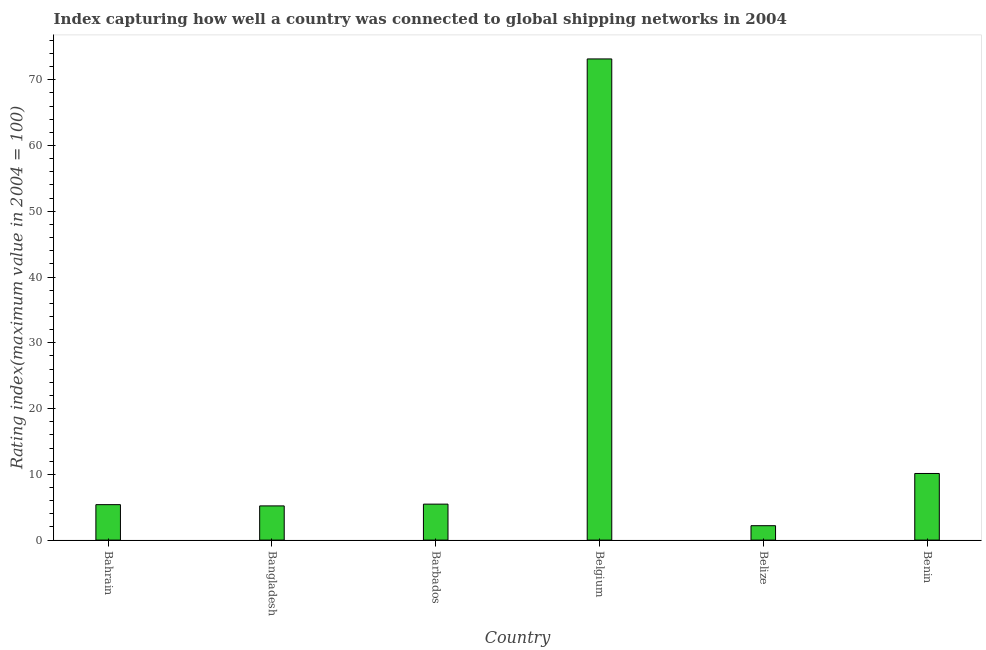Does the graph contain any zero values?
Offer a terse response. No. What is the title of the graph?
Make the answer very short. Index capturing how well a country was connected to global shipping networks in 2004. What is the label or title of the Y-axis?
Your response must be concise. Rating index(maximum value in 2004 = 100). What is the liner shipping connectivity index in Bahrain?
Ensure brevity in your answer.  5.39. Across all countries, what is the maximum liner shipping connectivity index?
Offer a very short reply. 73.16. Across all countries, what is the minimum liner shipping connectivity index?
Ensure brevity in your answer.  2.19. In which country was the liner shipping connectivity index maximum?
Ensure brevity in your answer.  Belgium. In which country was the liner shipping connectivity index minimum?
Make the answer very short. Belize. What is the sum of the liner shipping connectivity index?
Ensure brevity in your answer.  101.54. What is the difference between the liner shipping connectivity index in Bangladesh and Barbados?
Give a very brief answer. -0.27. What is the average liner shipping connectivity index per country?
Offer a very short reply. 16.92. What is the median liner shipping connectivity index?
Your answer should be very brief. 5.43. What is the ratio of the liner shipping connectivity index in Bahrain to that in Belize?
Give a very brief answer. 2.46. Is the liner shipping connectivity index in Belize less than that in Benin?
Give a very brief answer. Yes. What is the difference between the highest and the second highest liner shipping connectivity index?
Provide a short and direct response. 63.03. Is the sum of the liner shipping connectivity index in Belize and Benin greater than the maximum liner shipping connectivity index across all countries?
Make the answer very short. No. What is the difference between the highest and the lowest liner shipping connectivity index?
Give a very brief answer. 70.97. In how many countries, is the liner shipping connectivity index greater than the average liner shipping connectivity index taken over all countries?
Your response must be concise. 1. Are all the bars in the graph horizontal?
Ensure brevity in your answer.  No. What is the Rating index(maximum value in 2004 = 100) of Bahrain?
Offer a very short reply. 5.39. What is the Rating index(maximum value in 2004 = 100) in Barbados?
Your answer should be very brief. 5.47. What is the Rating index(maximum value in 2004 = 100) in Belgium?
Offer a very short reply. 73.16. What is the Rating index(maximum value in 2004 = 100) in Belize?
Offer a very short reply. 2.19. What is the Rating index(maximum value in 2004 = 100) of Benin?
Your response must be concise. 10.13. What is the difference between the Rating index(maximum value in 2004 = 100) in Bahrain and Bangladesh?
Ensure brevity in your answer.  0.19. What is the difference between the Rating index(maximum value in 2004 = 100) in Bahrain and Barbados?
Your response must be concise. -0.08. What is the difference between the Rating index(maximum value in 2004 = 100) in Bahrain and Belgium?
Keep it short and to the point. -67.77. What is the difference between the Rating index(maximum value in 2004 = 100) in Bahrain and Benin?
Offer a very short reply. -4.74. What is the difference between the Rating index(maximum value in 2004 = 100) in Bangladesh and Barbados?
Offer a very short reply. -0.27. What is the difference between the Rating index(maximum value in 2004 = 100) in Bangladesh and Belgium?
Provide a succinct answer. -67.96. What is the difference between the Rating index(maximum value in 2004 = 100) in Bangladesh and Belize?
Your answer should be compact. 3.01. What is the difference between the Rating index(maximum value in 2004 = 100) in Bangladesh and Benin?
Ensure brevity in your answer.  -4.93. What is the difference between the Rating index(maximum value in 2004 = 100) in Barbados and Belgium?
Your response must be concise. -67.69. What is the difference between the Rating index(maximum value in 2004 = 100) in Barbados and Belize?
Keep it short and to the point. 3.28. What is the difference between the Rating index(maximum value in 2004 = 100) in Barbados and Benin?
Give a very brief answer. -4.66. What is the difference between the Rating index(maximum value in 2004 = 100) in Belgium and Belize?
Your answer should be very brief. 70.97. What is the difference between the Rating index(maximum value in 2004 = 100) in Belgium and Benin?
Keep it short and to the point. 63.03. What is the difference between the Rating index(maximum value in 2004 = 100) in Belize and Benin?
Offer a terse response. -7.94. What is the ratio of the Rating index(maximum value in 2004 = 100) in Bahrain to that in Bangladesh?
Your answer should be compact. 1.04. What is the ratio of the Rating index(maximum value in 2004 = 100) in Bahrain to that in Belgium?
Give a very brief answer. 0.07. What is the ratio of the Rating index(maximum value in 2004 = 100) in Bahrain to that in Belize?
Provide a succinct answer. 2.46. What is the ratio of the Rating index(maximum value in 2004 = 100) in Bahrain to that in Benin?
Offer a terse response. 0.53. What is the ratio of the Rating index(maximum value in 2004 = 100) in Bangladesh to that in Barbados?
Offer a terse response. 0.95. What is the ratio of the Rating index(maximum value in 2004 = 100) in Bangladesh to that in Belgium?
Provide a succinct answer. 0.07. What is the ratio of the Rating index(maximum value in 2004 = 100) in Bangladesh to that in Belize?
Your response must be concise. 2.37. What is the ratio of the Rating index(maximum value in 2004 = 100) in Bangladesh to that in Benin?
Your response must be concise. 0.51. What is the ratio of the Rating index(maximum value in 2004 = 100) in Barbados to that in Belgium?
Give a very brief answer. 0.07. What is the ratio of the Rating index(maximum value in 2004 = 100) in Barbados to that in Belize?
Your answer should be compact. 2.5. What is the ratio of the Rating index(maximum value in 2004 = 100) in Barbados to that in Benin?
Give a very brief answer. 0.54. What is the ratio of the Rating index(maximum value in 2004 = 100) in Belgium to that in Belize?
Offer a very short reply. 33.41. What is the ratio of the Rating index(maximum value in 2004 = 100) in Belgium to that in Benin?
Your response must be concise. 7.22. What is the ratio of the Rating index(maximum value in 2004 = 100) in Belize to that in Benin?
Give a very brief answer. 0.22. 